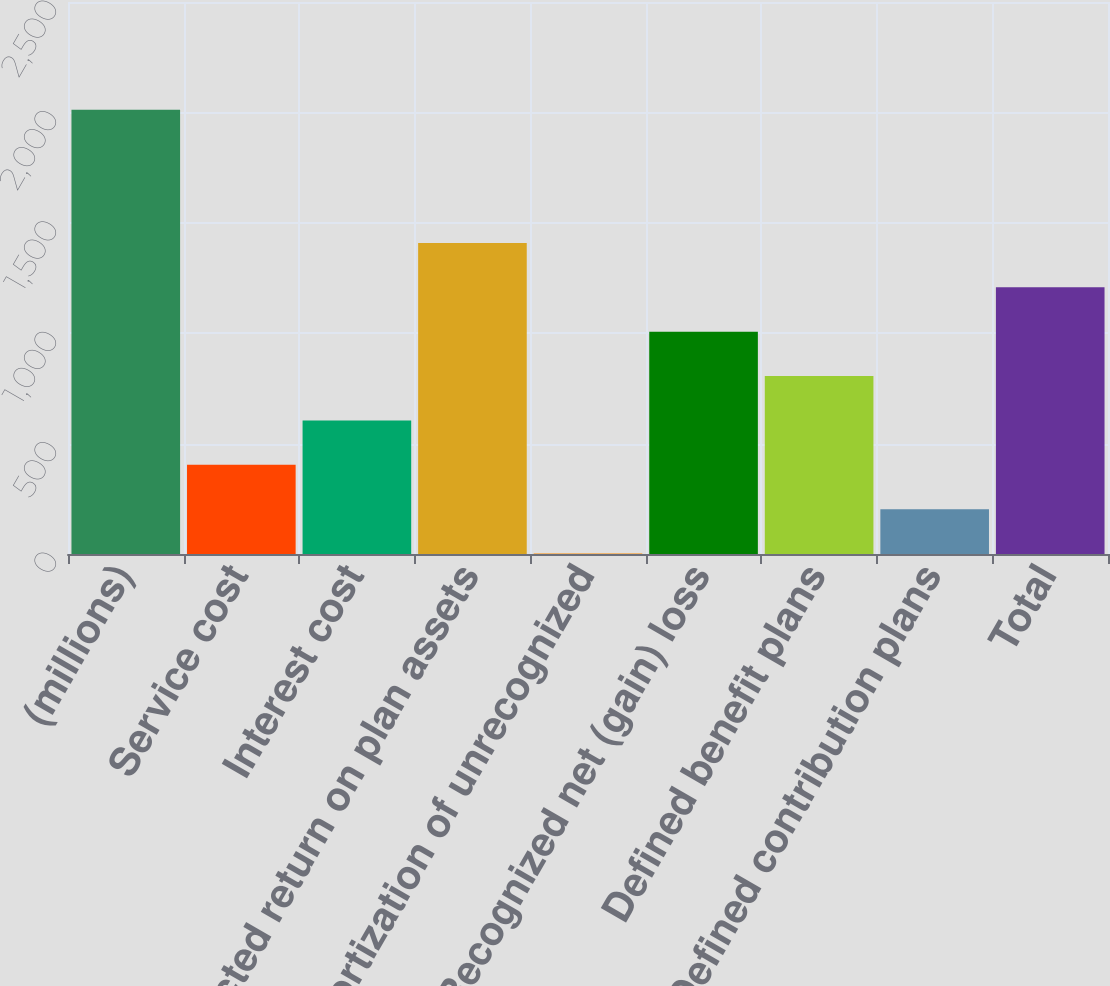Convert chart to OTSL. <chart><loc_0><loc_0><loc_500><loc_500><bar_chart><fcel>(millions)<fcel>Service cost<fcel>Interest cost<fcel>Expected return on plan assets<fcel>Amortization of unrecognized<fcel>Recognized net (gain) loss<fcel>Defined benefit plans<fcel>Defined contribution plans<fcel>Total<nl><fcel>2012<fcel>404<fcel>605<fcel>1409<fcel>2<fcel>1007<fcel>806<fcel>203<fcel>1208<nl></chart> 